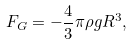Convert formula to latex. <formula><loc_0><loc_0><loc_500><loc_500>F _ { G } = - \frac { 4 } { 3 } \pi \rho g R ^ { 3 } ,</formula> 